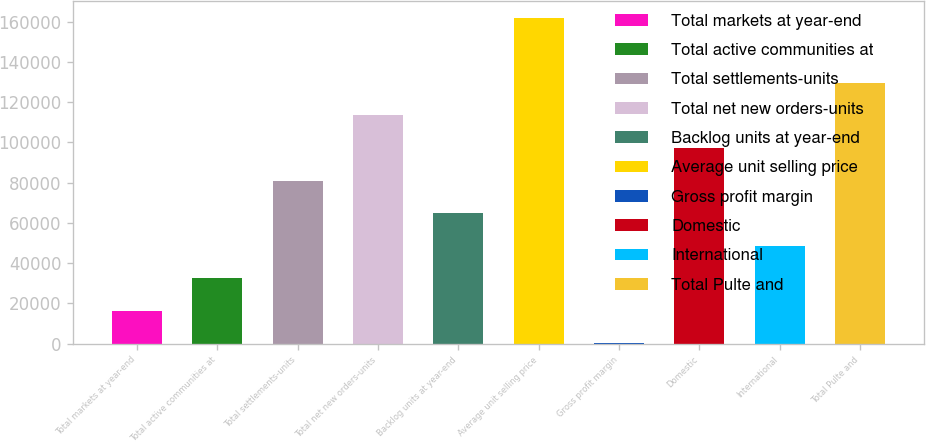Convert chart to OTSL. <chart><loc_0><loc_0><loc_500><loc_500><bar_chart><fcel>Total markets at year-end<fcel>Total active communities at<fcel>Total settlements-units<fcel>Total net new orders-units<fcel>Backlog units at year-end<fcel>Average unit selling price<fcel>Gross profit margin<fcel>Domestic<fcel>International<fcel>Total Pulte and<nl><fcel>16213.4<fcel>32411.9<fcel>81007.4<fcel>113404<fcel>64808.9<fcel>162000<fcel>14.9<fcel>97206<fcel>48610.4<fcel>129603<nl></chart> 